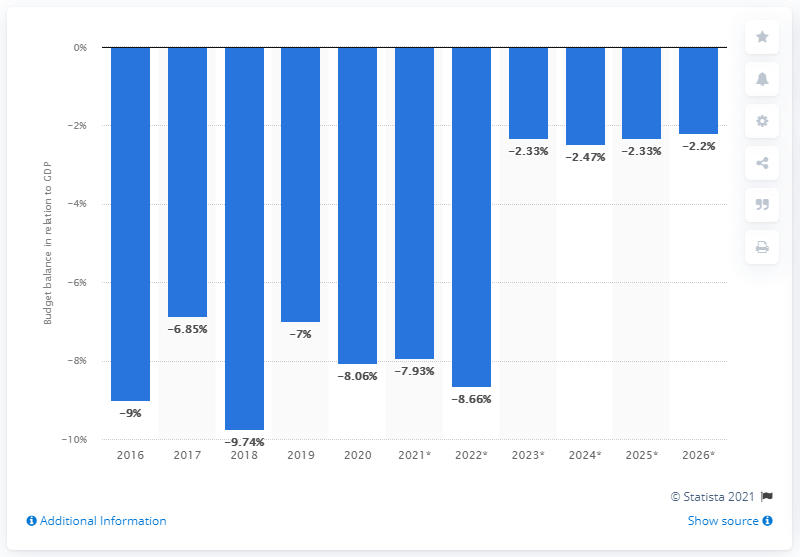Identify some key points in this picture. In 2020, Swaziland's budget balance in relation to GDP ended. 